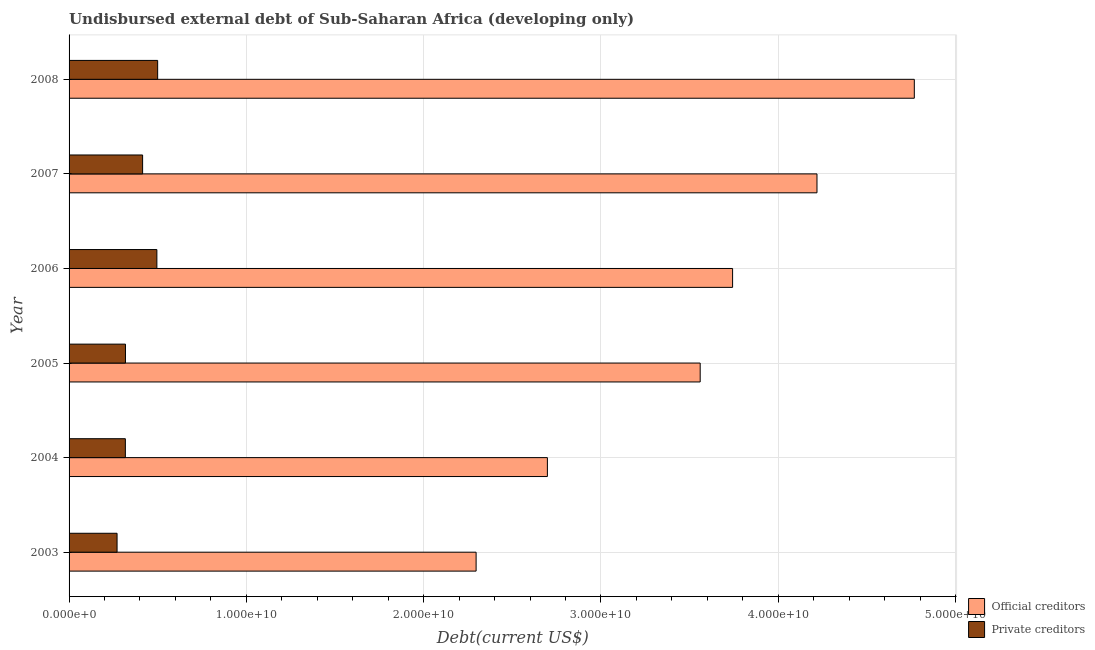How many groups of bars are there?
Give a very brief answer. 6. Are the number of bars on each tick of the Y-axis equal?
Provide a succinct answer. Yes. What is the label of the 2nd group of bars from the top?
Offer a very short reply. 2007. In how many cases, is the number of bars for a given year not equal to the number of legend labels?
Offer a very short reply. 0. What is the undisbursed external debt of private creditors in 2003?
Ensure brevity in your answer.  2.71e+09. Across all years, what is the maximum undisbursed external debt of official creditors?
Your answer should be compact. 4.77e+1. Across all years, what is the minimum undisbursed external debt of private creditors?
Provide a succinct answer. 2.71e+09. In which year was the undisbursed external debt of official creditors maximum?
Give a very brief answer. 2008. What is the total undisbursed external debt of private creditors in the graph?
Ensure brevity in your answer.  2.32e+1. What is the difference between the undisbursed external debt of private creditors in 2005 and that in 2007?
Keep it short and to the point. -9.67e+08. What is the difference between the undisbursed external debt of private creditors in 2006 and the undisbursed external debt of official creditors in 2007?
Your answer should be compact. -3.72e+1. What is the average undisbursed external debt of private creditors per year?
Your answer should be compact. 3.86e+09. In the year 2005, what is the difference between the undisbursed external debt of private creditors and undisbursed external debt of official creditors?
Your answer should be compact. -3.24e+1. In how many years, is the undisbursed external debt of private creditors greater than 10000000000 US$?
Offer a very short reply. 0. What is the ratio of the undisbursed external debt of private creditors in 2007 to that in 2008?
Make the answer very short. 0.83. What is the difference between the highest and the second highest undisbursed external debt of private creditors?
Keep it short and to the point. 4.46e+07. What is the difference between the highest and the lowest undisbursed external debt of private creditors?
Make the answer very short. 2.29e+09. Is the sum of the undisbursed external debt of private creditors in 2006 and 2007 greater than the maximum undisbursed external debt of official creditors across all years?
Provide a short and direct response. No. What does the 2nd bar from the top in 2003 represents?
Keep it short and to the point. Official creditors. What does the 2nd bar from the bottom in 2005 represents?
Make the answer very short. Private creditors. How many bars are there?
Give a very brief answer. 12. Are all the bars in the graph horizontal?
Your answer should be very brief. Yes. What is the difference between two consecutive major ticks on the X-axis?
Offer a very short reply. 1.00e+1. What is the title of the graph?
Your response must be concise. Undisbursed external debt of Sub-Saharan Africa (developing only). Does "Rural Population" appear as one of the legend labels in the graph?
Provide a short and direct response. No. What is the label or title of the X-axis?
Keep it short and to the point. Debt(current US$). What is the label or title of the Y-axis?
Your response must be concise. Year. What is the Debt(current US$) of Official creditors in 2003?
Provide a succinct answer. 2.30e+1. What is the Debt(current US$) in Private creditors in 2003?
Provide a short and direct response. 2.71e+09. What is the Debt(current US$) in Official creditors in 2004?
Make the answer very short. 2.70e+1. What is the Debt(current US$) in Private creditors in 2004?
Give a very brief answer. 3.17e+09. What is the Debt(current US$) in Official creditors in 2005?
Provide a short and direct response. 3.56e+1. What is the Debt(current US$) in Private creditors in 2005?
Your response must be concise. 3.18e+09. What is the Debt(current US$) in Official creditors in 2006?
Your answer should be very brief. 3.74e+1. What is the Debt(current US$) in Private creditors in 2006?
Make the answer very short. 4.95e+09. What is the Debt(current US$) of Official creditors in 2007?
Your answer should be very brief. 4.22e+1. What is the Debt(current US$) in Private creditors in 2007?
Provide a succinct answer. 4.15e+09. What is the Debt(current US$) of Official creditors in 2008?
Make the answer very short. 4.77e+1. What is the Debt(current US$) of Private creditors in 2008?
Keep it short and to the point. 5.00e+09. Across all years, what is the maximum Debt(current US$) in Official creditors?
Make the answer very short. 4.77e+1. Across all years, what is the maximum Debt(current US$) in Private creditors?
Your answer should be very brief. 5.00e+09. Across all years, what is the minimum Debt(current US$) of Official creditors?
Provide a succinct answer. 2.30e+1. Across all years, what is the minimum Debt(current US$) of Private creditors?
Your answer should be compact. 2.71e+09. What is the total Debt(current US$) in Official creditors in the graph?
Offer a terse response. 2.13e+11. What is the total Debt(current US$) of Private creditors in the graph?
Your response must be concise. 2.32e+1. What is the difference between the Debt(current US$) in Official creditors in 2003 and that in 2004?
Provide a short and direct response. -4.02e+09. What is the difference between the Debt(current US$) of Private creditors in 2003 and that in 2004?
Your answer should be compact. -4.67e+08. What is the difference between the Debt(current US$) of Official creditors in 2003 and that in 2005?
Provide a short and direct response. -1.26e+1. What is the difference between the Debt(current US$) in Private creditors in 2003 and that in 2005?
Ensure brevity in your answer.  -4.74e+08. What is the difference between the Debt(current US$) of Official creditors in 2003 and that in 2006?
Ensure brevity in your answer.  -1.45e+1. What is the difference between the Debt(current US$) of Private creditors in 2003 and that in 2006?
Your answer should be very brief. -2.25e+09. What is the difference between the Debt(current US$) of Official creditors in 2003 and that in 2007?
Ensure brevity in your answer.  -1.92e+1. What is the difference between the Debt(current US$) in Private creditors in 2003 and that in 2007?
Your answer should be very brief. -1.44e+09. What is the difference between the Debt(current US$) of Official creditors in 2003 and that in 2008?
Offer a terse response. -2.47e+1. What is the difference between the Debt(current US$) of Private creditors in 2003 and that in 2008?
Offer a very short reply. -2.29e+09. What is the difference between the Debt(current US$) of Official creditors in 2004 and that in 2005?
Provide a short and direct response. -8.62e+09. What is the difference between the Debt(current US$) of Private creditors in 2004 and that in 2005?
Your answer should be very brief. -6.60e+06. What is the difference between the Debt(current US$) in Official creditors in 2004 and that in 2006?
Ensure brevity in your answer.  -1.04e+1. What is the difference between the Debt(current US$) of Private creditors in 2004 and that in 2006?
Provide a succinct answer. -1.78e+09. What is the difference between the Debt(current US$) of Official creditors in 2004 and that in 2007?
Your answer should be very brief. -1.52e+1. What is the difference between the Debt(current US$) of Private creditors in 2004 and that in 2007?
Offer a terse response. -9.73e+08. What is the difference between the Debt(current US$) of Official creditors in 2004 and that in 2008?
Provide a succinct answer. -2.07e+1. What is the difference between the Debt(current US$) of Private creditors in 2004 and that in 2008?
Give a very brief answer. -1.82e+09. What is the difference between the Debt(current US$) of Official creditors in 2005 and that in 2006?
Offer a terse response. -1.83e+09. What is the difference between the Debt(current US$) in Private creditors in 2005 and that in 2006?
Give a very brief answer. -1.77e+09. What is the difference between the Debt(current US$) in Official creditors in 2005 and that in 2007?
Ensure brevity in your answer.  -6.59e+09. What is the difference between the Debt(current US$) of Private creditors in 2005 and that in 2007?
Give a very brief answer. -9.67e+08. What is the difference between the Debt(current US$) in Official creditors in 2005 and that in 2008?
Offer a very short reply. -1.21e+1. What is the difference between the Debt(current US$) of Private creditors in 2005 and that in 2008?
Ensure brevity in your answer.  -1.82e+09. What is the difference between the Debt(current US$) of Official creditors in 2006 and that in 2007?
Provide a succinct answer. -4.76e+09. What is the difference between the Debt(current US$) in Private creditors in 2006 and that in 2007?
Your answer should be very brief. 8.05e+08. What is the difference between the Debt(current US$) of Official creditors in 2006 and that in 2008?
Keep it short and to the point. -1.02e+1. What is the difference between the Debt(current US$) in Private creditors in 2006 and that in 2008?
Ensure brevity in your answer.  -4.46e+07. What is the difference between the Debt(current US$) of Official creditors in 2007 and that in 2008?
Provide a succinct answer. -5.49e+09. What is the difference between the Debt(current US$) of Private creditors in 2007 and that in 2008?
Make the answer very short. -8.49e+08. What is the difference between the Debt(current US$) of Official creditors in 2003 and the Debt(current US$) of Private creditors in 2004?
Your answer should be very brief. 1.98e+1. What is the difference between the Debt(current US$) in Official creditors in 2003 and the Debt(current US$) in Private creditors in 2005?
Ensure brevity in your answer.  1.98e+1. What is the difference between the Debt(current US$) of Official creditors in 2003 and the Debt(current US$) of Private creditors in 2006?
Provide a succinct answer. 1.80e+1. What is the difference between the Debt(current US$) of Official creditors in 2003 and the Debt(current US$) of Private creditors in 2007?
Provide a succinct answer. 1.88e+1. What is the difference between the Debt(current US$) of Official creditors in 2003 and the Debt(current US$) of Private creditors in 2008?
Provide a short and direct response. 1.80e+1. What is the difference between the Debt(current US$) in Official creditors in 2004 and the Debt(current US$) in Private creditors in 2005?
Your answer should be very brief. 2.38e+1. What is the difference between the Debt(current US$) in Official creditors in 2004 and the Debt(current US$) in Private creditors in 2006?
Make the answer very short. 2.20e+1. What is the difference between the Debt(current US$) of Official creditors in 2004 and the Debt(current US$) of Private creditors in 2007?
Offer a very short reply. 2.28e+1. What is the difference between the Debt(current US$) of Official creditors in 2004 and the Debt(current US$) of Private creditors in 2008?
Ensure brevity in your answer.  2.20e+1. What is the difference between the Debt(current US$) in Official creditors in 2005 and the Debt(current US$) in Private creditors in 2006?
Your answer should be very brief. 3.06e+1. What is the difference between the Debt(current US$) in Official creditors in 2005 and the Debt(current US$) in Private creditors in 2007?
Provide a short and direct response. 3.15e+1. What is the difference between the Debt(current US$) of Official creditors in 2005 and the Debt(current US$) of Private creditors in 2008?
Offer a very short reply. 3.06e+1. What is the difference between the Debt(current US$) of Official creditors in 2006 and the Debt(current US$) of Private creditors in 2007?
Provide a succinct answer. 3.33e+1. What is the difference between the Debt(current US$) in Official creditors in 2006 and the Debt(current US$) in Private creditors in 2008?
Offer a terse response. 3.24e+1. What is the difference between the Debt(current US$) of Official creditors in 2007 and the Debt(current US$) of Private creditors in 2008?
Give a very brief answer. 3.72e+1. What is the average Debt(current US$) in Official creditors per year?
Keep it short and to the point. 3.55e+1. What is the average Debt(current US$) in Private creditors per year?
Ensure brevity in your answer.  3.86e+09. In the year 2003, what is the difference between the Debt(current US$) in Official creditors and Debt(current US$) in Private creditors?
Your answer should be very brief. 2.03e+1. In the year 2004, what is the difference between the Debt(current US$) of Official creditors and Debt(current US$) of Private creditors?
Offer a very short reply. 2.38e+1. In the year 2005, what is the difference between the Debt(current US$) of Official creditors and Debt(current US$) of Private creditors?
Ensure brevity in your answer.  3.24e+1. In the year 2006, what is the difference between the Debt(current US$) in Official creditors and Debt(current US$) in Private creditors?
Your answer should be very brief. 3.25e+1. In the year 2007, what is the difference between the Debt(current US$) in Official creditors and Debt(current US$) in Private creditors?
Make the answer very short. 3.80e+1. In the year 2008, what is the difference between the Debt(current US$) of Official creditors and Debt(current US$) of Private creditors?
Offer a very short reply. 4.27e+1. What is the ratio of the Debt(current US$) of Official creditors in 2003 to that in 2004?
Offer a terse response. 0.85. What is the ratio of the Debt(current US$) of Private creditors in 2003 to that in 2004?
Give a very brief answer. 0.85. What is the ratio of the Debt(current US$) of Official creditors in 2003 to that in 2005?
Ensure brevity in your answer.  0.64. What is the ratio of the Debt(current US$) of Private creditors in 2003 to that in 2005?
Ensure brevity in your answer.  0.85. What is the ratio of the Debt(current US$) in Official creditors in 2003 to that in 2006?
Offer a terse response. 0.61. What is the ratio of the Debt(current US$) of Private creditors in 2003 to that in 2006?
Your response must be concise. 0.55. What is the ratio of the Debt(current US$) of Official creditors in 2003 to that in 2007?
Your response must be concise. 0.54. What is the ratio of the Debt(current US$) in Private creditors in 2003 to that in 2007?
Ensure brevity in your answer.  0.65. What is the ratio of the Debt(current US$) in Official creditors in 2003 to that in 2008?
Your answer should be very brief. 0.48. What is the ratio of the Debt(current US$) in Private creditors in 2003 to that in 2008?
Your answer should be compact. 0.54. What is the ratio of the Debt(current US$) of Official creditors in 2004 to that in 2005?
Your response must be concise. 0.76. What is the ratio of the Debt(current US$) of Official creditors in 2004 to that in 2006?
Provide a short and direct response. 0.72. What is the ratio of the Debt(current US$) of Private creditors in 2004 to that in 2006?
Provide a succinct answer. 0.64. What is the ratio of the Debt(current US$) of Official creditors in 2004 to that in 2007?
Make the answer very short. 0.64. What is the ratio of the Debt(current US$) of Private creditors in 2004 to that in 2007?
Keep it short and to the point. 0.77. What is the ratio of the Debt(current US$) of Official creditors in 2004 to that in 2008?
Ensure brevity in your answer.  0.57. What is the ratio of the Debt(current US$) of Private creditors in 2004 to that in 2008?
Your answer should be very brief. 0.64. What is the ratio of the Debt(current US$) in Official creditors in 2005 to that in 2006?
Your answer should be very brief. 0.95. What is the ratio of the Debt(current US$) in Private creditors in 2005 to that in 2006?
Make the answer very short. 0.64. What is the ratio of the Debt(current US$) of Official creditors in 2005 to that in 2007?
Offer a terse response. 0.84. What is the ratio of the Debt(current US$) in Private creditors in 2005 to that in 2007?
Provide a short and direct response. 0.77. What is the ratio of the Debt(current US$) of Official creditors in 2005 to that in 2008?
Keep it short and to the point. 0.75. What is the ratio of the Debt(current US$) in Private creditors in 2005 to that in 2008?
Ensure brevity in your answer.  0.64. What is the ratio of the Debt(current US$) in Official creditors in 2006 to that in 2007?
Offer a terse response. 0.89. What is the ratio of the Debt(current US$) of Private creditors in 2006 to that in 2007?
Your answer should be compact. 1.19. What is the ratio of the Debt(current US$) of Official creditors in 2006 to that in 2008?
Your answer should be very brief. 0.79. What is the ratio of the Debt(current US$) of Official creditors in 2007 to that in 2008?
Make the answer very short. 0.88. What is the ratio of the Debt(current US$) in Private creditors in 2007 to that in 2008?
Your answer should be compact. 0.83. What is the difference between the highest and the second highest Debt(current US$) in Official creditors?
Ensure brevity in your answer.  5.49e+09. What is the difference between the highest and the second highest Debt(current US$) in Private creditors?
Keep it short and to the point. 4.46e+07. What is the difference between the highest and the lowest Debt(current US$) in Official creditors?
Give a very brief answer. 2.47e+1. What is the difference between the highest and the lowest Debt(current US$) in Private creditors?
Give a very brief answer. 2.29e+09. 